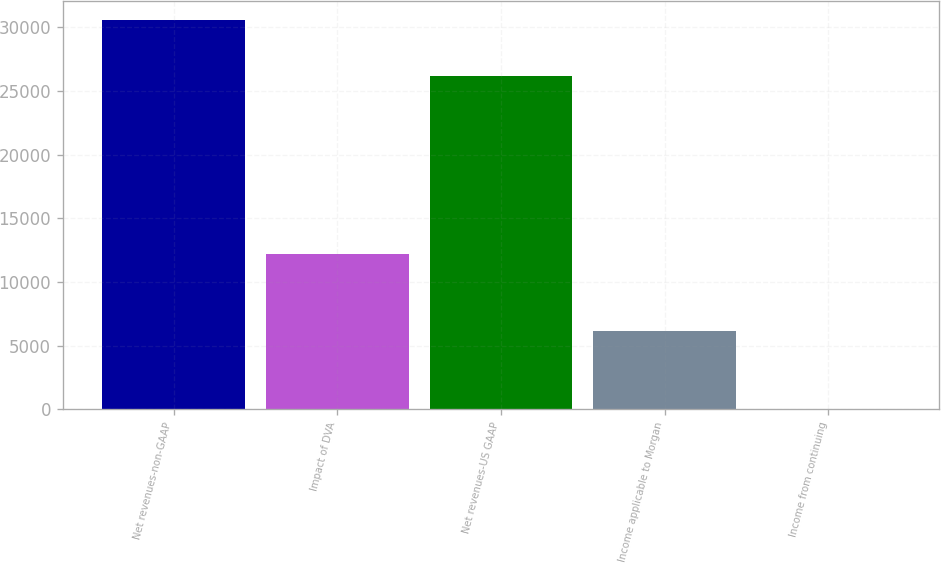Convert chart. <chart><loc_0><loc_0><loc_500><loc_500><bar_chart><fcel>Net revenues-non-GAAP<fcel>Impact of DVA<fcel>Net revenues-US GAAP<fcel>Income applicable to Morgan<fcel>Income from continuing<nl><fcel>30580<fcel>12232<fcel>26178<fcel>6116.02<fcel>0.02<nl></chart> 